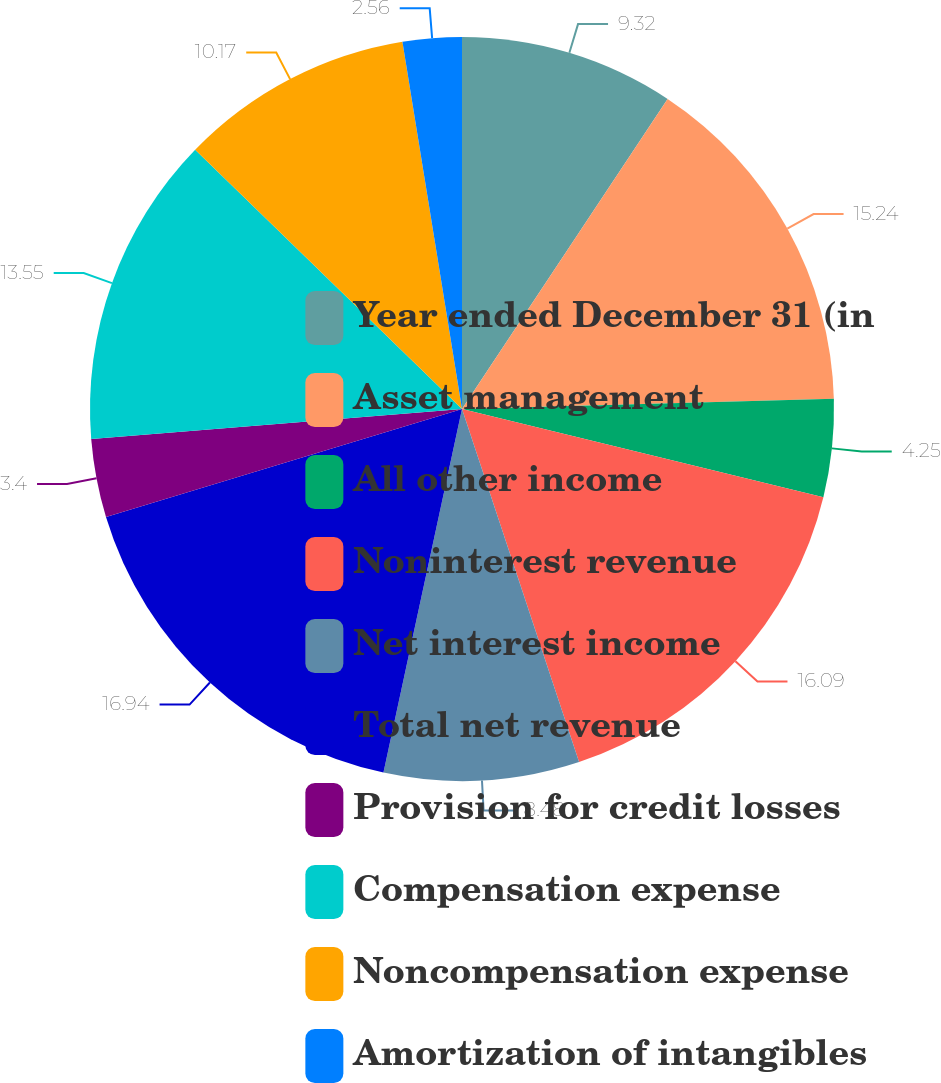Convert chart to OTSL. <chart><loc_0><loc_0><loc_500><loc_500><pie_chart><fcel>Year ended December 31 (in<fcel>Asset management<fcel>All other income<fcel>Noninterest revenue<fcel>Net interest income<fcel>Total net revenue<fcel>Provision for credit losses<fcel>Compensation expense<fcel>Noncompensation expense<fcel>Amortization of intangibles<nl><fcel>9.32%<fcel>15.24%<fcel>4.25%<fcel>16.09%<fcel>8.48%<fcel>16.93%<fcel>3.4%<fcel>13.55%<fcel>10.17%<fcel>2.56%<nl></chart> 